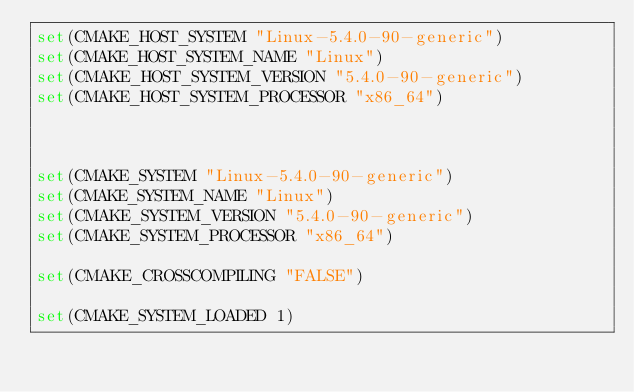Convert code to text. <code><loc_0><loc_0><loc_500><loc_500><_CMake_>set(CMAKE_HOST_SYSTEM "Linux-5.4.0-90-generic")
set(CMAKE_HOST_SYSTEM_NAME "Linux")
set(CMAKE_HOST_SYSTEM_VERSION "5.4.0-90-generic")
set(CMAKE_HOST_SYSTEM_PROCESSOR "x86_64")



set(CMAKE_SYSTEM "Linux-5.4.0-90-generic")
set(CMAKE_SYSTEM_NAME "Linux")
set(CMAKE_SYSTEM_VERSION "5.4.0-90-generic")
set(CMAKE_SYSTEM_PROCESSOR "x86_64")

set(CMAKE_CROSSCOMPILING "FALSE")

set(CMAKE_SYSTEM_LOADED 1)
</code> 